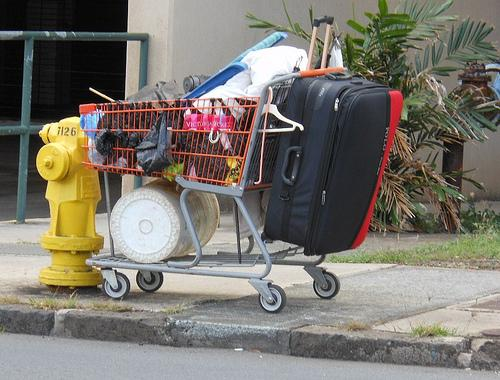Count the number of items in the shopping cart. There are at least 4 items in the shopping cart. Describe the condition and location of the shopping cart in the image. The shopping cart is full, parked near a yellow fire hydrant, and on the sidewalk. What are the identifying features of the suitcase in the image? The suitcase is blue with a red stripe and a blue handle. What are the colors of the grocery cart and its notable features? The grocery cart is red and gray, with a red bed and silver frame, and contains multiple items including a blue suitcase with a red stripe. Provide a detailed description of the items on the lower shelf of the shopping cart. There is a white bucket and a small black plastic bag on the lower shelf of the shopping cart. Give a brief overview of the scene depicted in the image. In the image, a full shopping cart is by a yellow fire hydrant on a sidewalk, with a blue suitcase hooked on it and various items inside. What type of bag can be found inside the shopping cart? A Victoria's Secret bag is inside the shopping cart. Identify the color of the suitcase that is hooked to the shopping cart. The suitcase hooked to the shopping cart is blue. Mention the color of the fire hydrant and its activity or state in this picture. The fire hydrant is yellow and appears inactive or not in use. What object appears to be hanging on the shopping cart? A white hanger is hanging on the shopping cart. Explain the coloration of the suitcase in the image. The suitcase is blue with a red stripe. State the position of the green and brown leaves in the image. On a plant in the background Speculate the purpose of the small black plastic bag in the image. Not enough information to determine its purpose Establish what the shopping cart is filled with. The shopping cart is filled with various items, including a Victoria's Secret bag and clothes. Point out the objects surrounding the fire hydrant. A shopping cart and a curb Identify the object hanging from the shopping cart. A white hanger Detail any noticeable numbers on the fire hydrant. 7126 Pinpoint the location of the black and red suitcase. Hanging on the back of the shopping cart Describe where the white bucket is placed in relation to the shopping cart. The white bucket is on the bottom of the shopping cart. What color is the suitcase attached to the shopping cart? Blue Interpret the relationship between the fire hydrant and the sidewalk. The fire hydrant is on the sidewalk. Discuss the specific location of the yellow fire hydrant. The yellow fire hydrant is on the sidewalk near the shopping cart. Does the suitcase have any markings on it? If so, what color are they? Yes, red markings Determine the location of the Victoria's Secret bag. The Victoria's Secret bag is inside the shopping cart. Choose the correct description for the suitcase: (A) Black and blue suitcase (B) Blue suitcase with green markings (C) Blue suitcase with red stripe (C) Blue suitcase with red stripe Judge the color of the fire hydrant next to the grocery cart. Yellow Verify the color of the shopping cart bed. Red Examine the interaction between the suitcase and the shopping cart. The suitcase is hooked on the back of the shopping cart. Classify the material of the shopping cart frame. Silver 